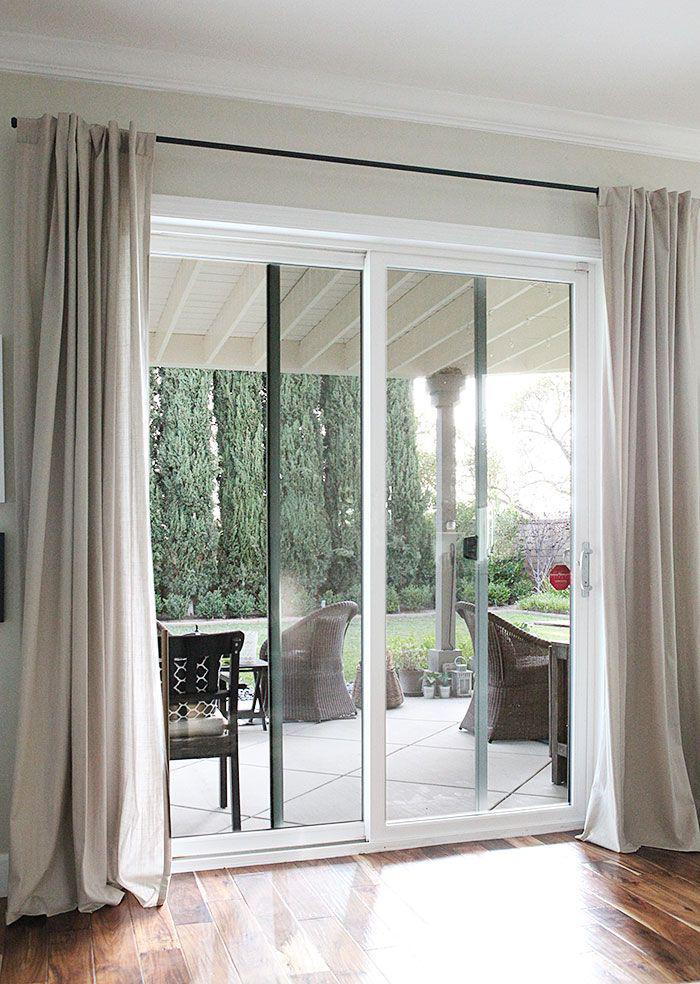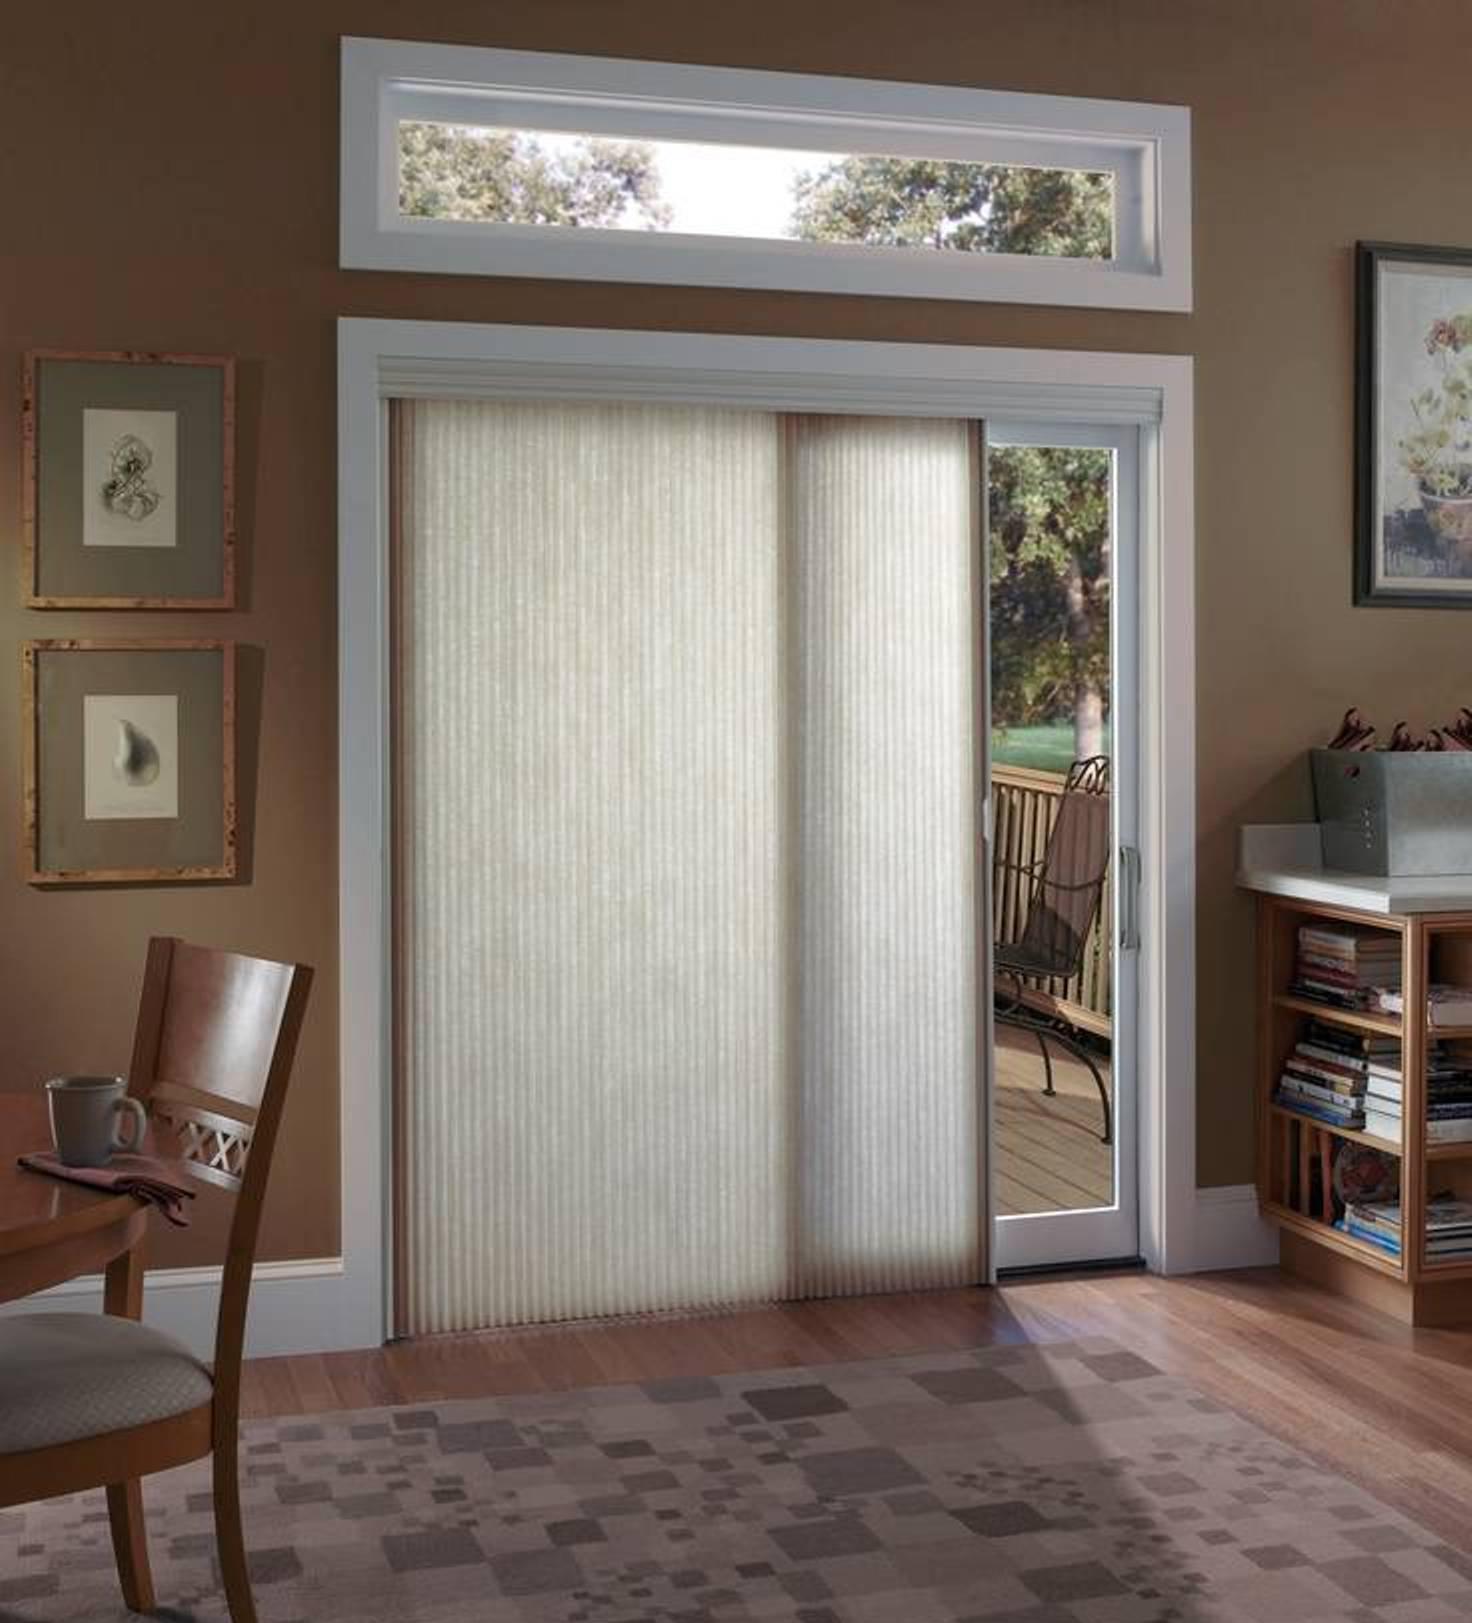The first image is the image on the left, the second image is the image on the right. Examine the images to the left and right. Is the description "The patio doors in one of the images are framed by curtains on either side." accurate? Answer yes or no. Yes. The first image is the image on the left, the second image is the image on the right. For the images displayed, is the sentence "The windows in the left image have drapes." factually correct? Answer yes or no. Yes. 